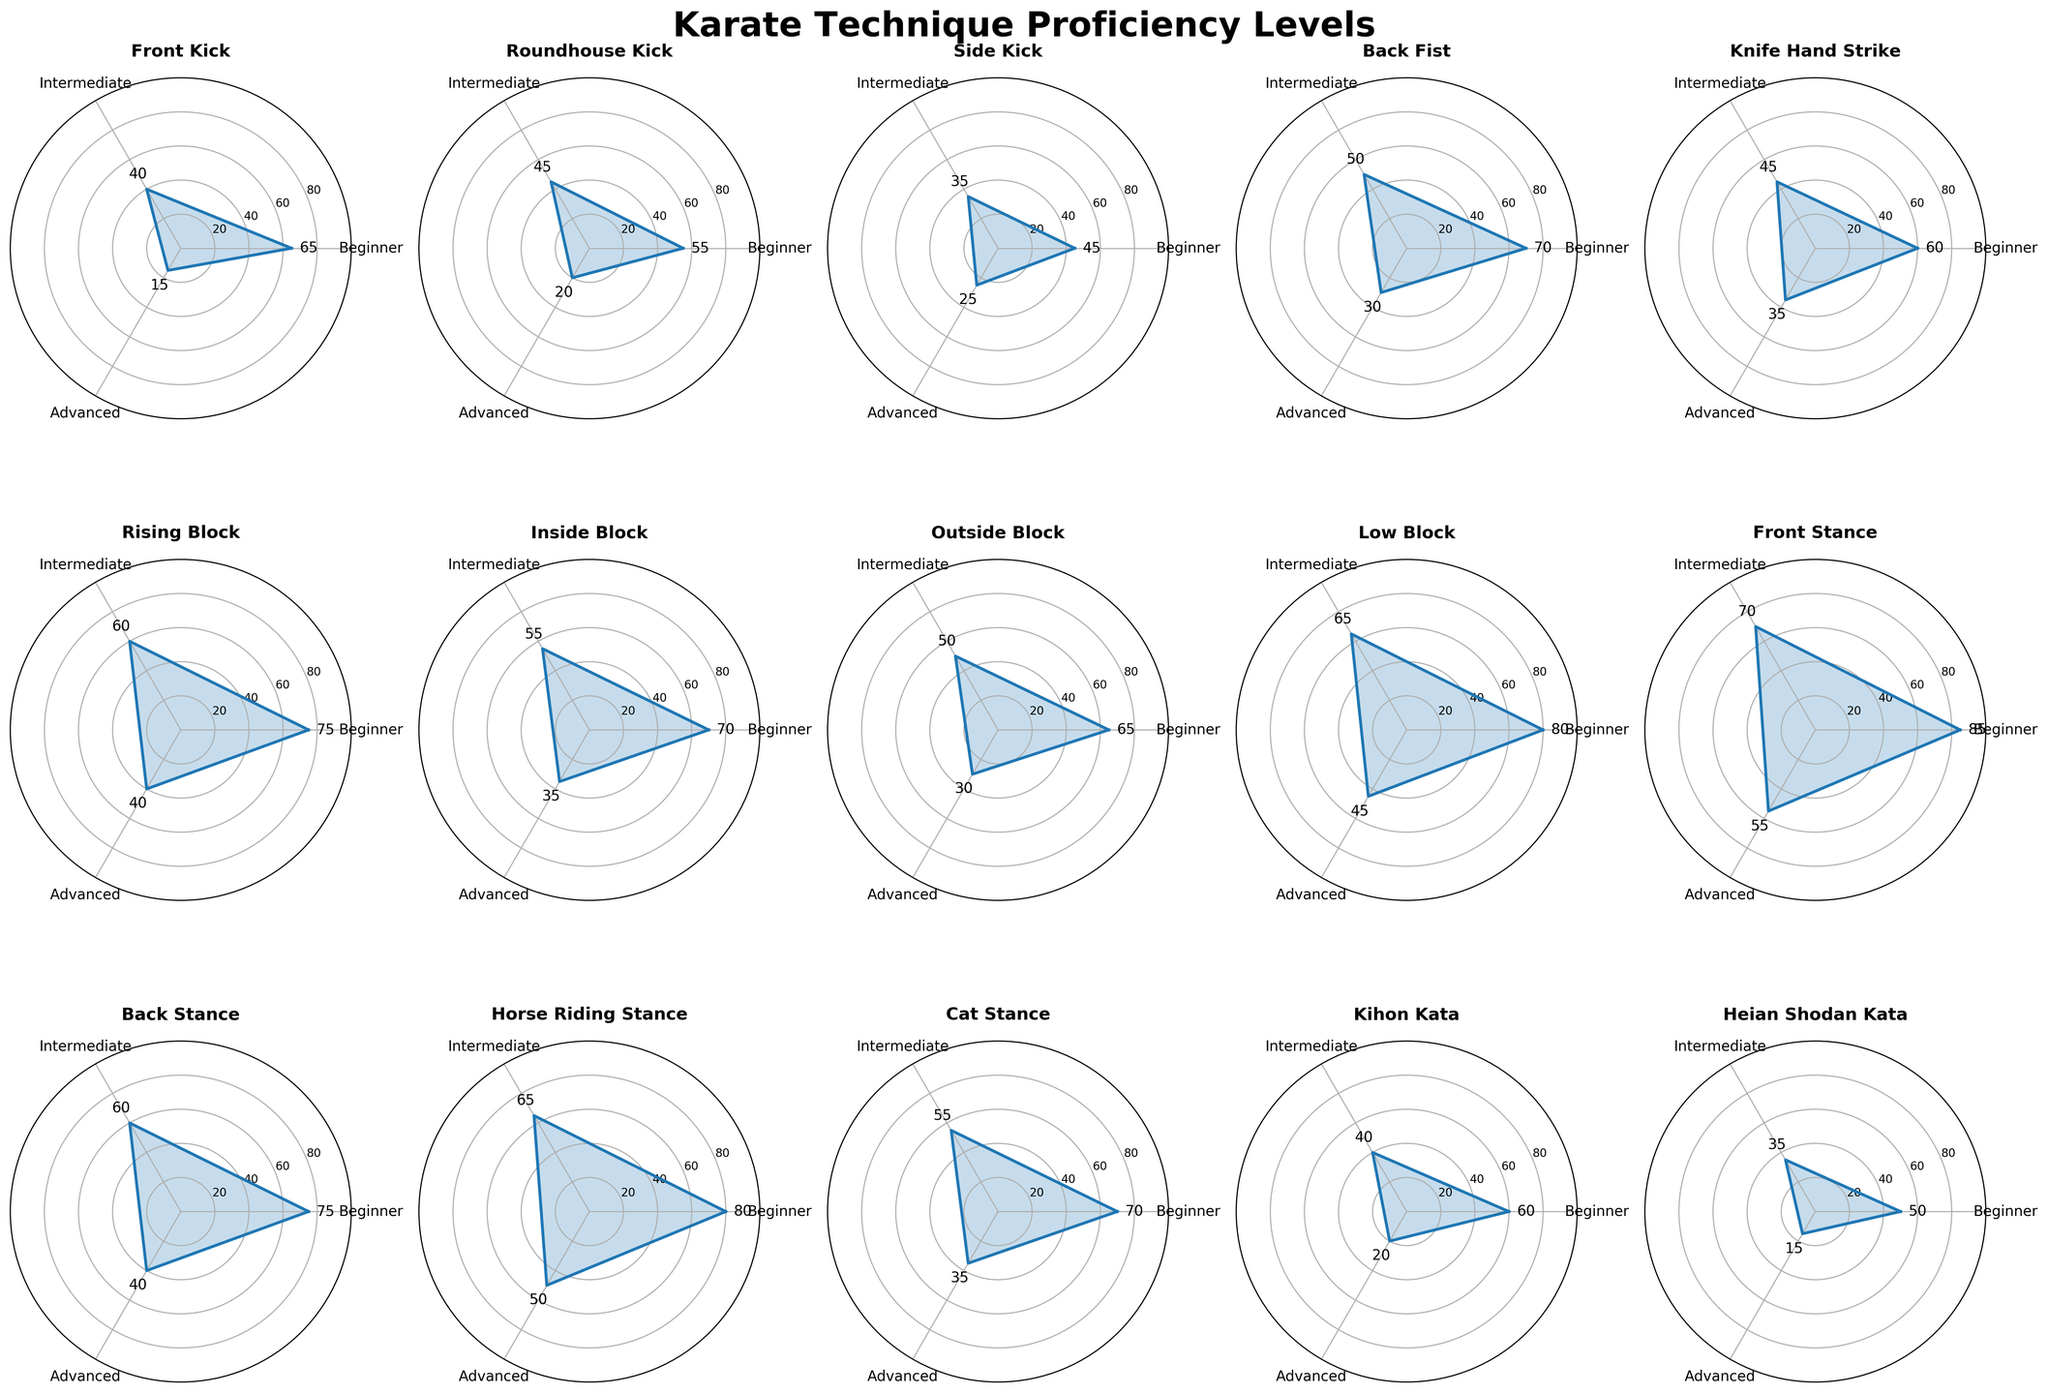What is the title of the figure? The title is located at the top of the figure, displaying a brief description of what the chart represents.
Answer: Karate Technique Proficiency Levels Which technique has the highest beginner proficiency level? By observing the gauge charts, we see the technique with the highest value in the 'Beginner' section.
Answer: Front Stance How many techniques have an intermediate proficiency level greater than 50? By counting the charts where the intermediate section exceeds 50, we identify the techniques.
Answer: 8 What is the sum of the advanced proficiency levels for the Front Kick and Side Kick? Adding 15 from Front Kick and 25 from Side Kick gives the total.
Answer: 40 Which technique has a higher advanced level, Knife Hand Strike or Back Fist? Comparing the advanced proficiency values of Knife Hand Strike and Back Fist, Knife Hand Strike has 35, and Back Fist has 30.
Answer: Knife Hand Strike What is the difference between the beginner and advanced levels for Cat Stance? Subtract the advanced level from the beginner level for Cat Stance. 70 - 35 = 35.
Answer: 35 Which technique has the smallest difference between intermediate and advanced levels? Calculate the differences for all techniques and identify the smallest one; e.g., for Kihon Kata: 40 - 20 = 20, for Front Stance: 70 - 55 = 15, etc.
Answer: Front Stance (15) How many techniques have at least one proficiency level over 60? Counting the number of charts where any section exceeds 60, we identify the techniques.
Answer: 9 Which technique shows a balanced proficiency across beginner, intermediate, and advanced levels? Look for the technique charts where values are closely clustered around the same range, e.g., Rising Block: 75, 60, 40.
Answer: Rising Block What is the average intermediate proficiency level across all techniques? Sum all intermediate values (40 + 45 + 35 + 50 + 45 + 60 + 55 + 50 + 65 + 70 + 60 + 65 + 55 + 40 + 35 = 760) and divide by the number of techniques (15).
Answer: 50.7 